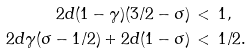<formula> <loc_0><loc_0><loc_500><loc_500>2 d ( 1 - \gamma ) ( 3 / 2 - \sigma ) \, & < \, 1 , \\ 2 d \gamma ( \sigma - 1 / 2 ) + 2 d ( 1 - \sigma ) \, & < \, 1 / 2 .</formula> 